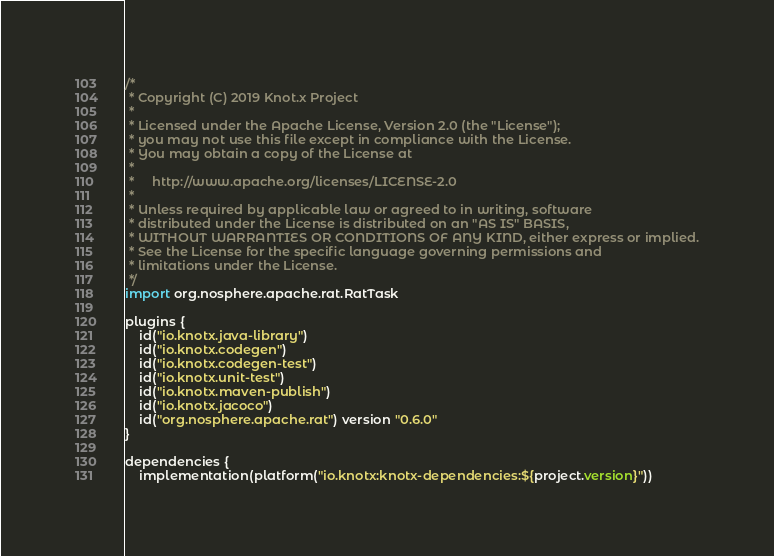<code> <loc_0><loc_0><loc_500><loc_500><_Kotlin_>/*
 * Copyright (C) 2019 Knot.x Project
 *
 * Licensed under the Apache License, Version 2.0 (the "License");
 * you may not use this file except in compliance with the License.
 * You may obtain a copy of the License at
 *
 *     http://www.apache.org/licenses/LICENSE-2.0
 *
 * Unless required by applicable law or agreed to in writing, software
 * distributed under the License is distributed on an "AS IS" BASIS,
 * WITHOUT WARRANTIES OR CONDITIONS OF ANY KIND, either express or implied.
 * See the License for the specific language governing permissions and
 * limitations under the License.
 */
import org.nosphere.apache.rat.RatTask

plugins {
    id("io.knotx.java-library")
    id("io.knotx.codegen")
    id("io.knotx.codegen-test")
    id("io.knotx.unit-test")
    id("io.knotx.maven-publish")
    id("io.knotx.jacoco")
    id("org.nosphere.apache.rat") version "0.6.0"
}

dependencies {
    implementation(platform("io.knotx:knotx-dependencies:${project.version}"))
</code> 